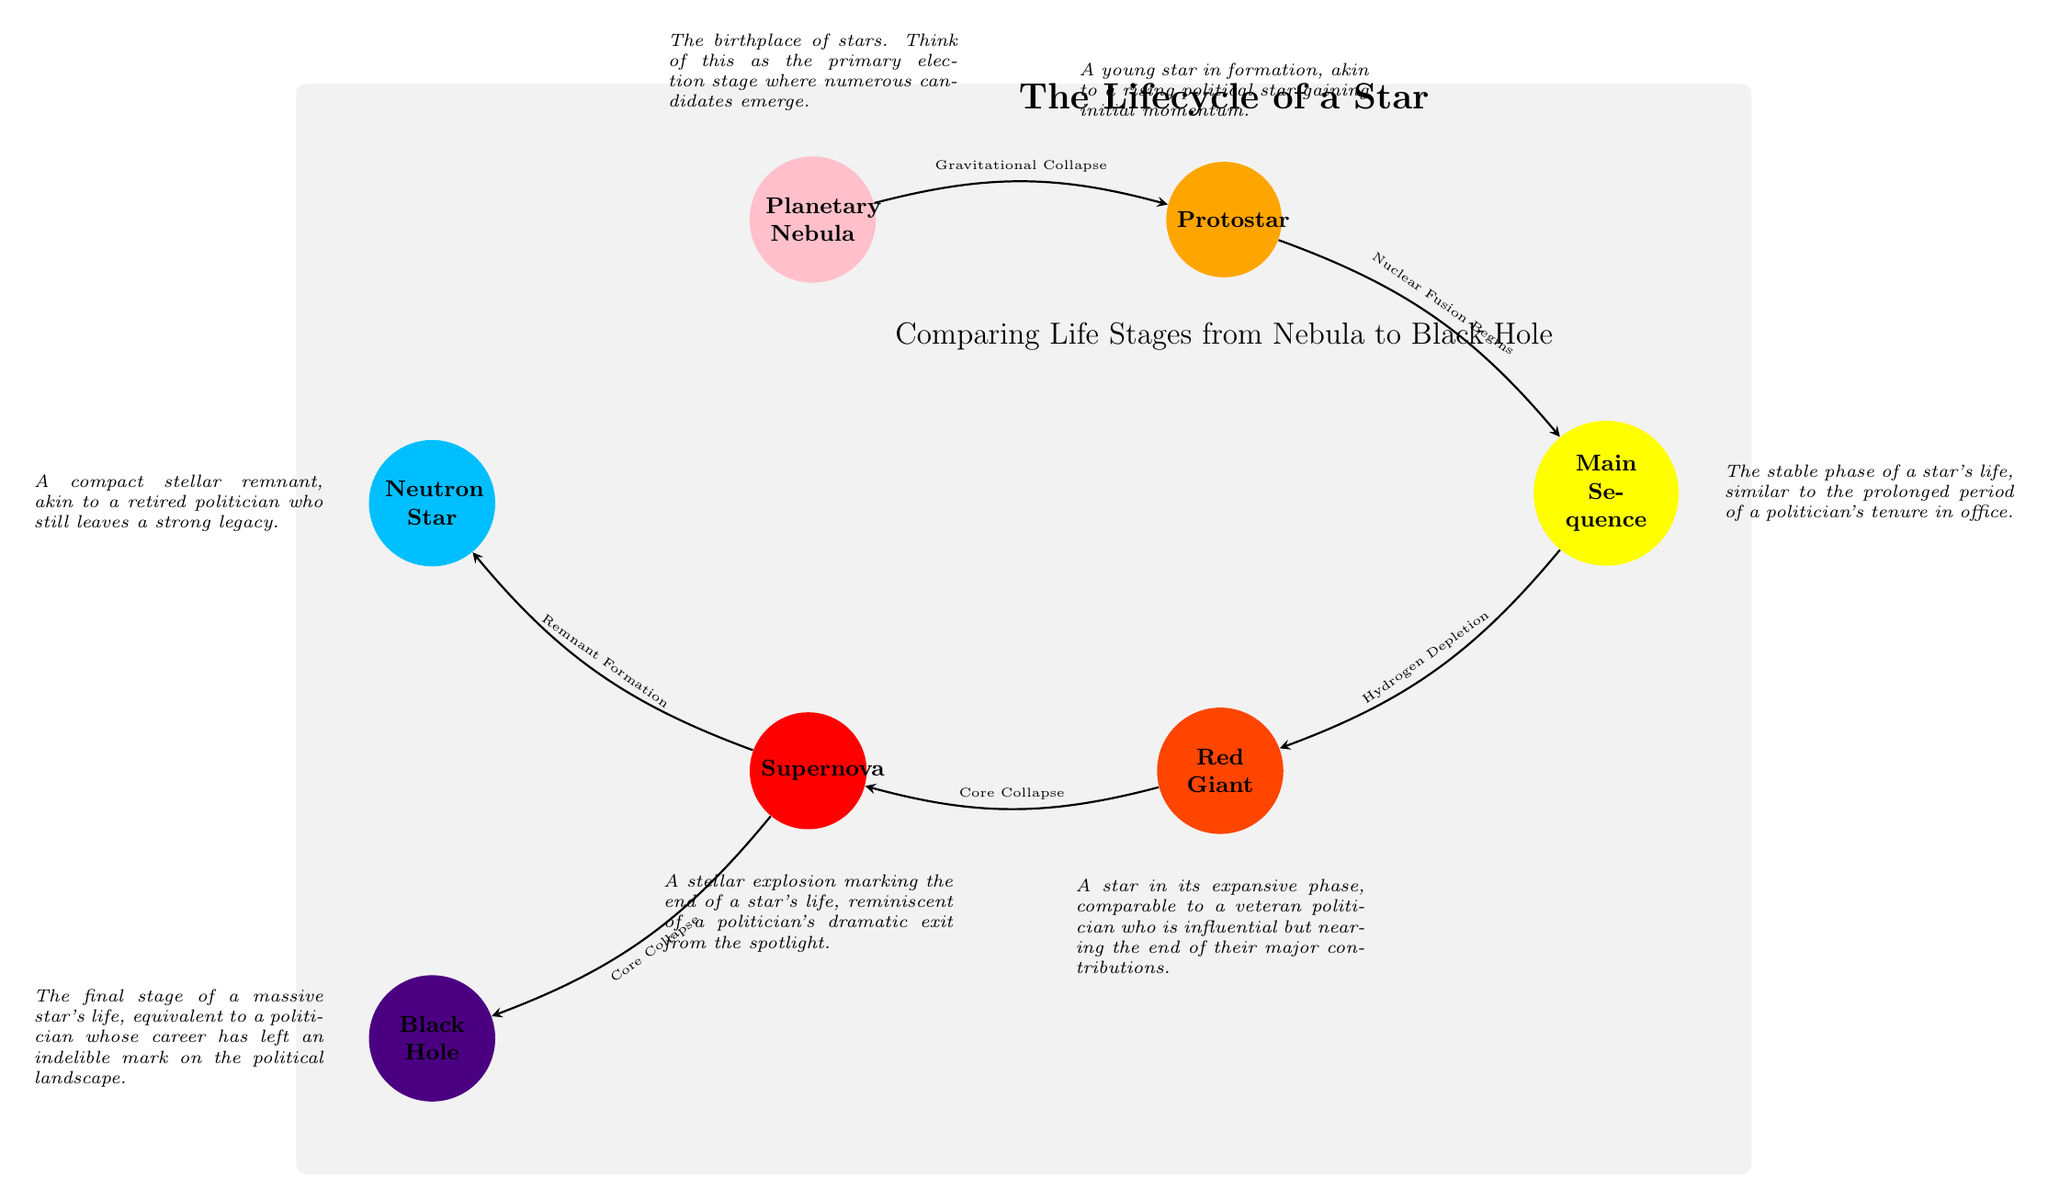What is the first stage of a star's lifecycle? The diagram begins with the "Planetary Nebula," which is indicated as the starting point of the stellar lifecycle.
Answer: Planetary Nebula What do we call the stage after a Protostar? Following "Protostar," the next stage is "Main Sequence," which is directly connected with an arrow in the diagram.
Answer: Main Sequence How many total stages are depicted in the lifecycle of a star? The diagram includes a total of seven stages: Planetary Nebula, Protostar, Main Sequence, Red Giant, Supernova, Neutron Star, and Black Hole. By counting each individual stage, we arrive at seven.
Answer: 7 Which stage is represented by the color purple? The final stage of the lifecycle, "Black Hole," is represented by the color purple, as indicated by the RGB code in the diagram.
Answer: Black Hole What event leads from Red Giant to Supernova? The transition from "Red Giant" to "Supernova" is facilitated by "Core Collapse," which is specified on the connecting arrow in the diagram.
Answer: Core Collapse How does a Neutron Star relate to a Supernova? The "Neutron Star" is a result of the "Supernova," marked by the "Remnant Formation" transition which occurs after the Supernova explosion. This indicates that a Neutron Star is one possible outcome after a Supernova transition in stellar evolution.
Answer: Remnant Formation Which stage corresponds to the narrative of a "veteran politician"? The "Red Giant" stage is described in the diagram as comparable to a "veteran politician," indicating that it reflects a stage of expansion and influence before the star's life concludes.
Answer: Red Giant What is the transition called when reaching the Main Sequence from a Protostar? The transition from "Protostar" to "Main Sequence" is marked as "Nuclear Fusion Begins," which signifies a major change in a star's lifecycle leading to stability.
Answer: Nuclear Fusion Begins 